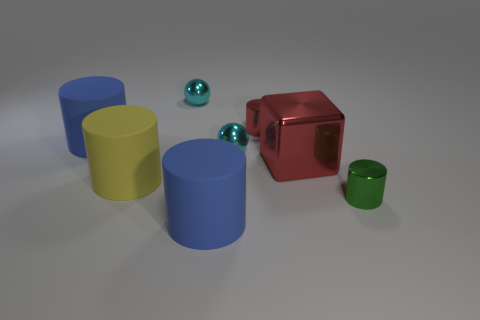How many things are red metallic cylinders or cylinders on the left side of the large metal cube?
Offer a terse response. 4. What is the material of the big cube?
Provide a short and direct response. Metal. Is there anything else that has the same color as the large metal thing?
Provide a succinct answer. Yes. Is the shape of the yellow rubber thing the same as the small red shiny thing?
Provide a short and direct response. Yes. What is the size of the metal cylinder that is to the left of the small green shiny object that is in front of the tiny cylinder that is behind the red metal cube?
Make the answer very short. Small. How many other objects are there of the same material as the small green cylinder?
Your answer should be very brief. 4. What is the color of the large object that is in front of the small green shiny cylinder?
Offer a terse response. Blue. There is a tiny thing on the right side of the red metal thing behind the blue thing behind the large red shiny cube; what is its material?
Make the answer very short. Metal. Is there a red thing of the same shape as the big yellow matte thing?
Your answer should be very brief. Yes. There is a red shiny object that is the same size as the yellow cylinder; what shape is it?
Provide a succinct answer. Cube. 